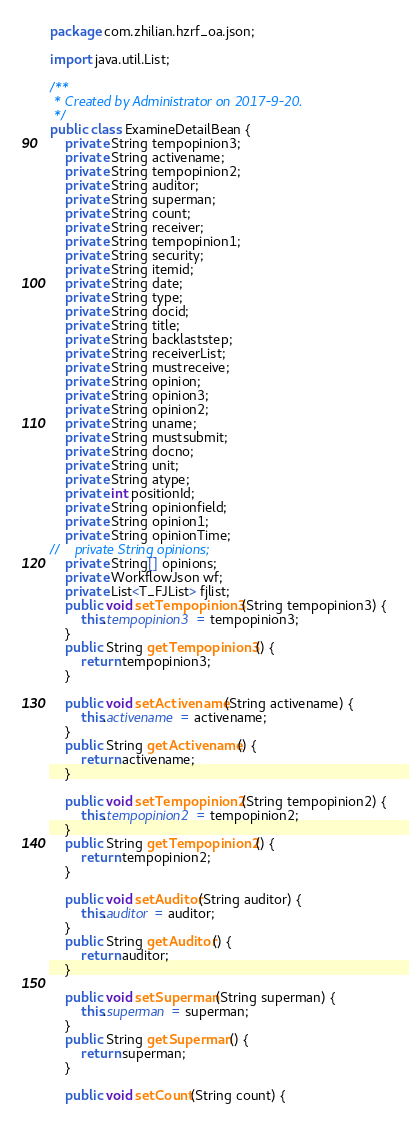Convert code to text. <code><loc_0><loc_0><loc_500><loc_500><_Java_>package com.zhilian.hzrf_oa.json;

import java.util.List;

/**
 * Created by Administrator on 2017-9-20.
 */
public class ExamineDetailBean {
    private String tempopinion3;
    private String activename;
    private String tempopinion2;
    private String auditor;
    private String superman;
    private String count;
    private String receiver;
    private String tempopinion1;
    private String security;
    private String itemid;
    private String date;
    private String type;
    private String docid;
    private String title;
    private String backlaststep;
    private String receiverList;
    private String mustreceive;
    private String opinion;
    private String opinion3;
    private String opinion2;
    private String uname;
    private String mustsubmit;
    private String docno;
    private String unit;
    private String atype;
    private int positionId;
    private String opinionfield;
    private String opinion1;
    private String opinionTime;
//    private String opinions;
    private String[] opinions;
    private WorkflowJson wf;
    private List<T_FJList> fjlist;
    public void setTempopinion3(String tempopinion3) {
        this.tempopinion3 = tempopinion3;
    }
    public String getTempopinion3() {
        return tempopinion3;
    }

    public void setActivename(String activename) {
        this.activename = activename;
    }
    public String getActivename() {
        return activename;
    }

    public void setTempopinion2(String tempopinion2) {
        this.tempopinion2 = tempopinion2;
    }
    public String getTempopinion2() {
        return tempopinion2;
    }

    public void setAuditor(String auditor) {
        this.auditor = auditor;
    }
    public String getAuditor() {
        return auditor;
    }

    public void setSuperman(String superman) {
        this.superman = superman;
    }
    public String getSuperman() {
        return superman;
    }

    public void setCount(String count) {</code> 